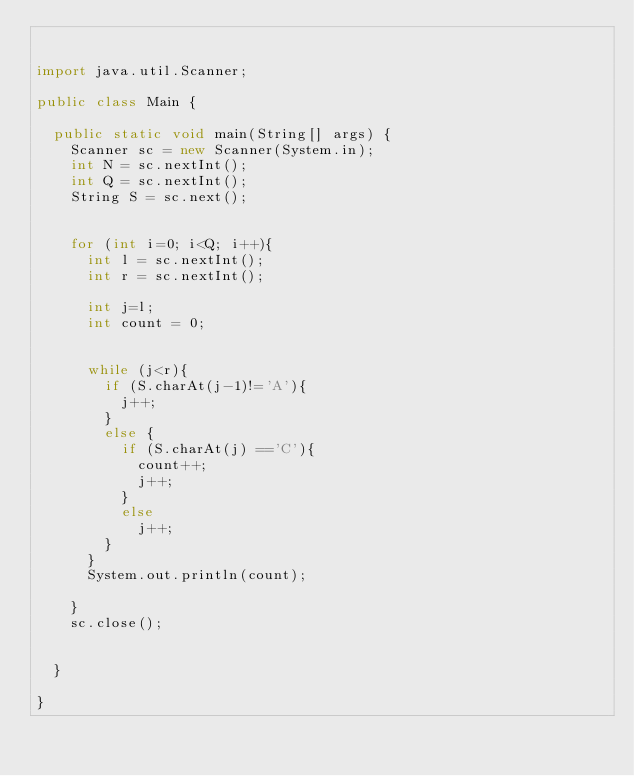Convert code to text. <code><loc_0><loc_0><loc_500><loc_500><_Java_>

import java.util.Scanner;

public class Main {

	public static void main(String[] args) {
		Scanner sc = new Scanner(System.in);
		int N = sc.nextInt();
		int Q = sc.nextInt();
		String S = sc.next();
		
		
		for (int i=0; i<Q; i++){
			int l = sc.nextInt();
			int r = sc.nextInt();
			
			int j=l;
			int count = 0;
	
		
			while (j<r){
				if (S.charAt(j-1)!='A'){
					j++;
				}
				else {
					if (S.charAt(j) =='C'){
						count++;
						j++;
					}
					else
						j++;
				}
			}
			System.out.println(count);
			
		}
		sc.close();
		

	}

}
</code> 